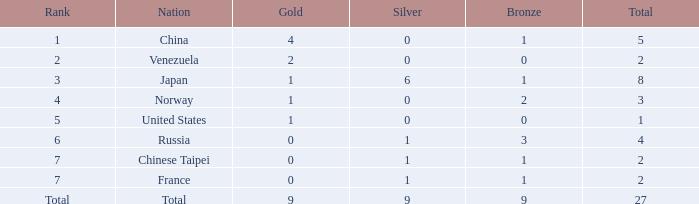What is the total number of Bronze when gold is more than 1 and nation is total? 1.0. 